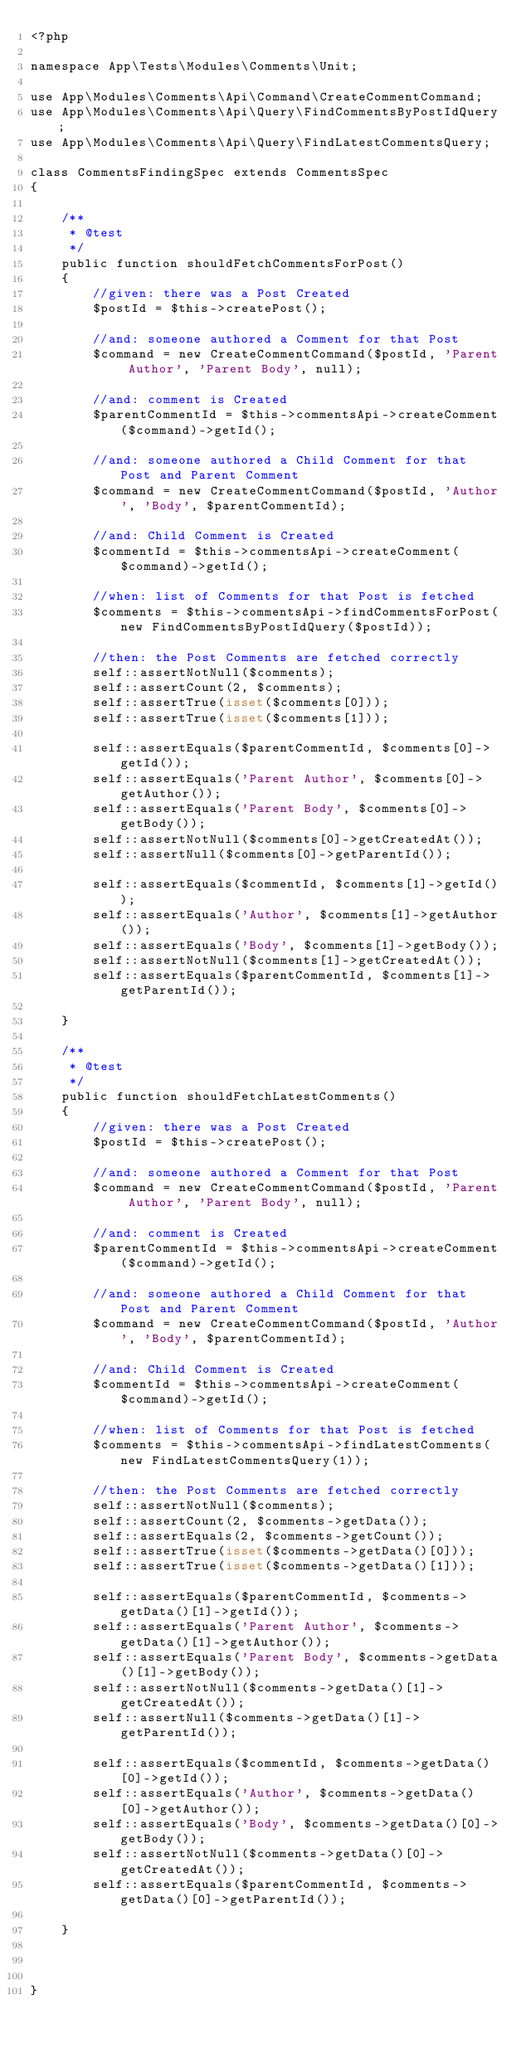Convert code to text. <code><loc_0><loc_0><loc_500><loc_500><_PHP_><?php

namespace App\Tests\Modules\Comments\Unit;

use App\Modules\Comments\Api\Command\CreateCommentCommand;
use App\Modules\Comments\Api\Query\FindCommentsByPostIdQuery;
use App\Modules\Comments\Api\Query\FindLatestCommentsQuery;

class CommentsFindingSpec extends CommentsSpec
{

    /**
     * @test
     */
    public function shouldFetchCommentsForPost()
    {
        //given: there was a Post Created
        $postId = $this->createPost();

        //and: someone authored a Comment for that Post
        $command = new CreateCommentCommand($postId, 'Parent Author', 'Parent Body', null);

        //and: comment is Created
        $parentCommentId = $this->commentsApi->createComment($command)->getId();

        //and: someone authored a Child Comment for that Post and Parent Comment
        $command = new CreateCommentCommand($postId, 'Author', 'Body', $parentCommentId);

        //and: Child Comment is Created
        $commentId = $this->commentsApi->createComment($command)->getId();

        //when: list of Comments for that Post is fetched
        $comments = $this->commentsApi->findCommentsForPost(new FindCommentsByPostIdQuery($postId));

        //then: the Post Comments are fetched correctly
        self::assertNotNull($comments);
        self::assertCount(2, $comments);
        self::assertTrue(isset($comments[0]));
        self::assertTrue(isset($comments[1]));

        self::assertEquals($parentCommentId, $comments[0]->getId());
        self::assertEquals('Parent Author', $comments[0]->getAuthor());
        self::assertEquals('Parent Body', $comments[0]->getBody());
        self::assertNotNull($comments[0]->getCreatedAt());
        self::assertNull($comments[0]->getParentId());

        self::assertEquals($commentId, $comments[1]->getId());
        self::assertEquals('Author', $comments[1]->getAuthor());
        self::assertEquals('Body', $comments[1]->getBody());
        self::assertNotNull($comments[1]->getCreatedAt());
        self::assertEquals($parentCommentId, $comments[1]->getParentId());

    }

    /**
     * @test
     */
    public function shouldFetchLatestComments()
    {
        //given: there was a Post Created
        $postId = $this->createPost();

        //and: someone authored a Comment for that Post
        $command = new CreateCommentCommand($postId, 'Parent Author', 'Parent Body', null);

        //and: comment is Created
        $parentCommentId = $this->commentsApi->createComment($command)->getId();

        //and: someone authored a Child Comment for that Post and Parent Comment
        $command = new CreateCommentCommand($postId, 'Author', 'Body', $parentCommentId);

        //and: Child Comment is Created
        $commentId = $this->commentsApi->createComment($command)->getId();

        //when: list of Comments for that Post is fetched
        $comments = $this->commentsApi->findLatestComments(new FindLatestCommentsQuery(1));

        //then: the Post Comments are fetched correctly
        self::assertNotNull($comments);
        self::assertCount(2, $comments->getData());
        self::assertEquals(2, $comments->getCount());
        self::assertTrue(isset($comments->getData()[0]));
        self::assertTrue(isset($comments->getData()[1]));

        self::assertEquals($parentCommentId, $comments->getData()[1]->getId());
        self::assertEquals('Parent Author', $comments->getData()[1]->getAuthor());
        self::assertEquals('Parent Body', $comments->getData()[1]->getBody());
        self::assertNotNull($comments->getData()[1]->getCreatedAt());
        self::assertNull($comments->getData()[1]->getParentId());

        self::assertEquals($commentId, $comments->getData()[0]->getId());
        self::assertEquals('Author', $comments->getData()[0]->getAuthor());
        self::assertEquals('Body', $comments->getData()[0]->getBody());
        self::assertNotNull($comments->getData()[0]->getCreatedAt());
        self::assertEquals($parentCommentId, $comments->getData()[0]->getParentId());

    }



}</code> 